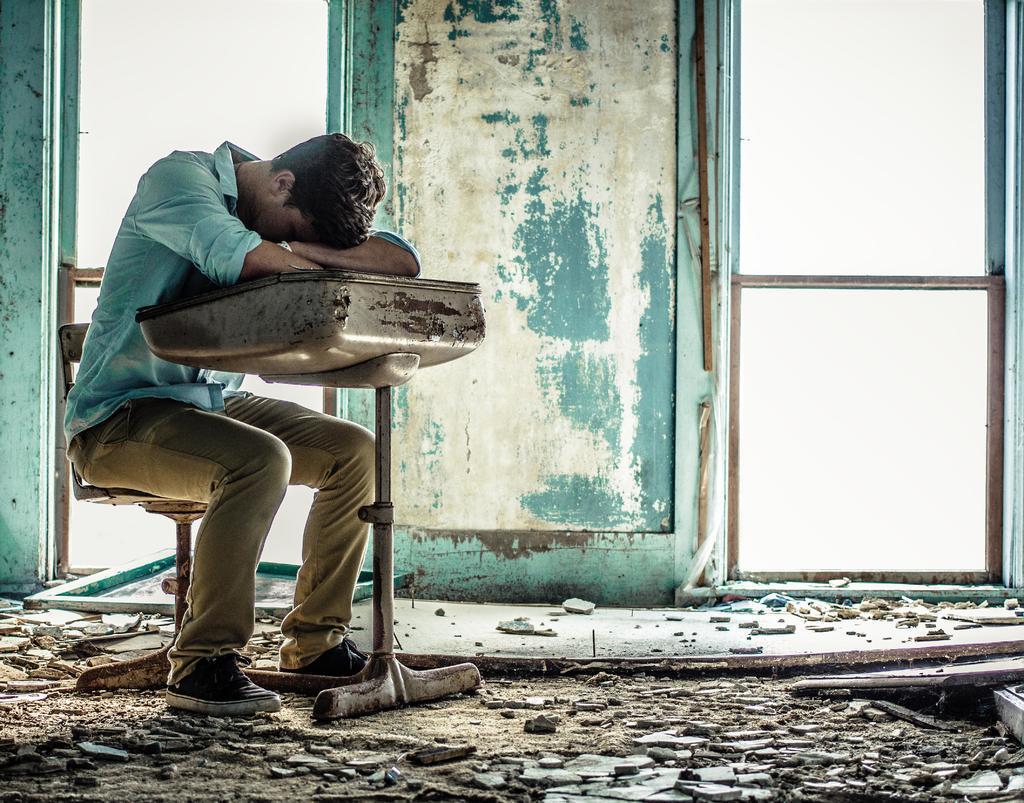In one or two sentences, can you explain what this image depicts? In the foreground of this image, on the left, there is a man sitting on the chair and leaning on a table. At the bottom, there is debris. In the background, there is a wall and two window. 